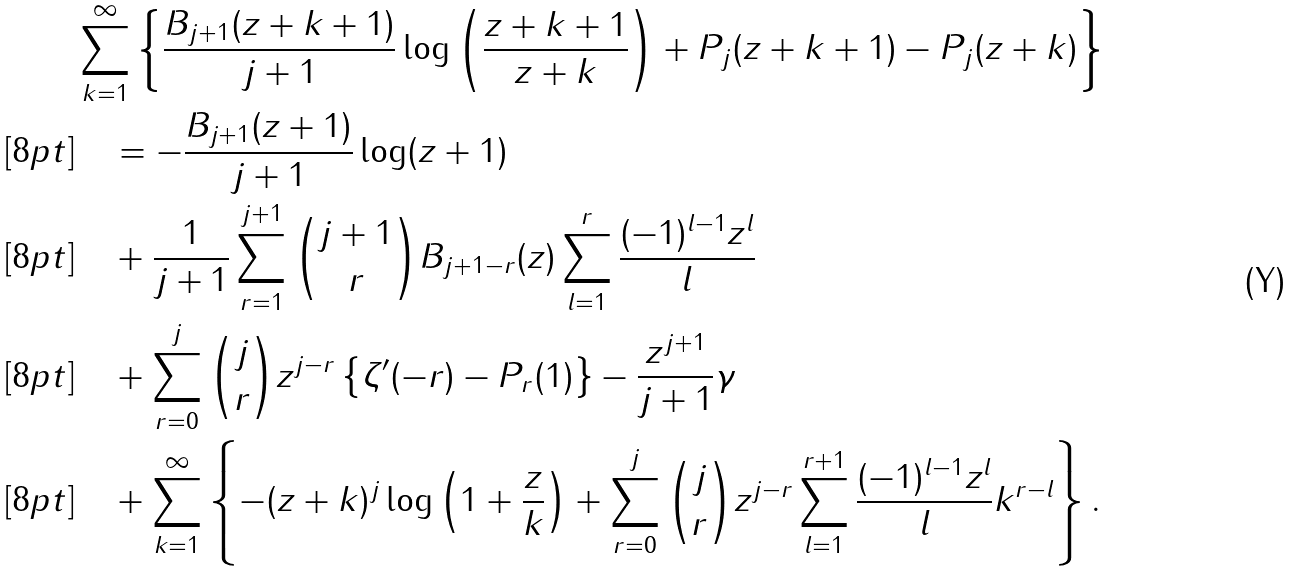<formula> <loc_0><loc_0><loc_500><loc_500>& \sum _ { k = 1 } ^ { \infty } \left \{ \frac { B _ { j + 1 } ( z + k + 1 ) } { j + 1 } \log \left ( \frac { z + k + 1 } { z + k } \right ) + P _ { j } ( z + k + 1 ) - P _ { j } ( z + k ) \right \} \\ [ 8 p t ] & \quad = - \frac { B _ { j + 1 } ( z + 1 ) } { j + 1 } \log ( z + 1 ) \\ [ 8 p t ] & \quad + \frac { 1 } { j + 1 } \sum _ { r = 1 } ^ { j + 1 } \binom { j + 1 } { r } B _ { j + 1 - r } ( z ) \sum _ { l = 1 } ^ { r } \frac { ( - 1 ) ^ { l - 1 } z ^ { l } } { l } \\ [ 8 p t ] & \quad + \sum _ { r = 0 } ^ { j } \binom { j } { r } z ^ { j - r } \left \{ \zeta ^ { \prime } ( - r ) - P _ { r } ( 1 ) \right \} - \frac { z ^ { j + 1 } } { j + 1 } \gamma \\ [ 8 p t ] & \quad + \sum _ { k = 1 } ^ { \infty } \left \{ - ( z + k ) ^ { j } \log \left ( 1 + \frac { z } { k } \right ) + \sum _ { r = 0 } ^ { j } \binom { j } { r } z ^ { j - r } \sum _ { l = 1 } ^ { r + 1 } \frac { ( - 1 ) ^ { l - 1 } z ^ { l } } { l } k ^ { r - l } \right \} .</formula> 